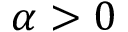Convert formula to latex. <formula><loc_0><loc_0><loc_500><loc_500>\alpha > 0</formula> 